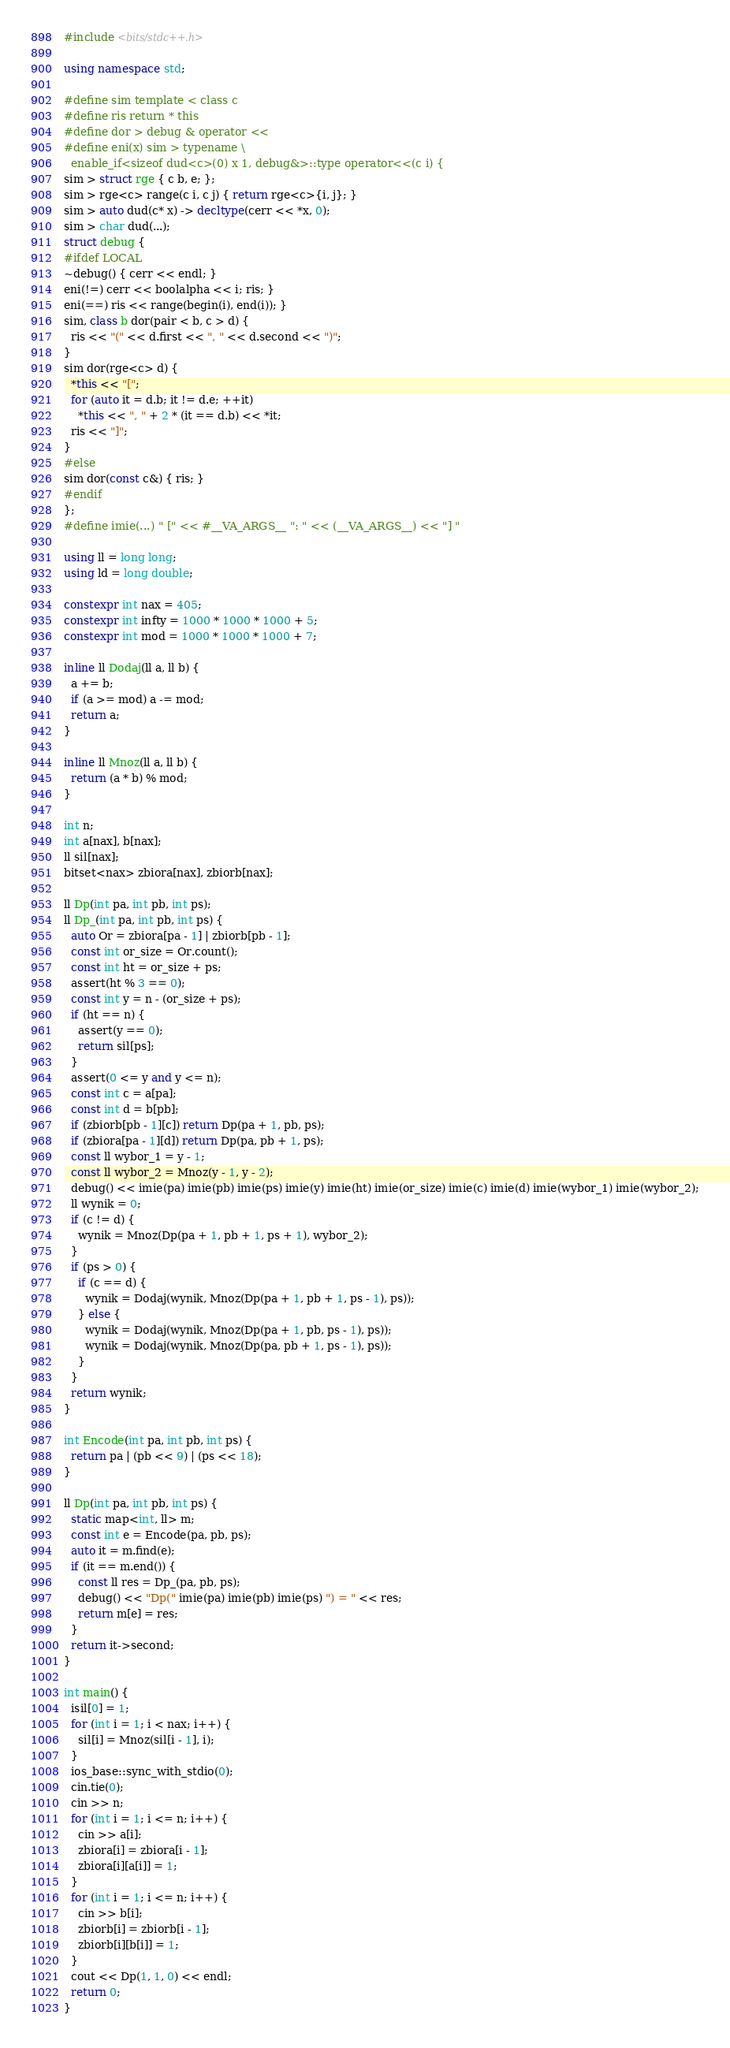<code> <loc_0><loc_0><loc_500><loc_500><_C++_>#include <bits/stdc++.h>
 
using namespace std;
 
#define sim template < class c
#define ris return * this
#define dor > debug & operator <<
#define eni(x) sim > typename \
  enable_if<sizeof dud<c>(0) x 1, debug&>::type operator<<(c i) {
sim > struct rge { c b, e; };
sim > rge<c> range(c i, c j) { return rge<c>{i, j}; }
sim > auto dud(c* x) -> decltype(cerr << *x, 0);
sim > char dud(...);
struct debug {
#ifdef LOCAL
~debug() { cerr << endl; }
eni(!=) cerr << boolalpha << i; ris; }
eni(==) ris << range(begin(i), end(i)); }
sim, class b dor(pair < b, c > d) {
  ris << "(" << d.first << ", " << d.second << ")";
}
sim dor(rge<c> d) {
  *this << "[";
  for (auto it = d.b; it != d.e; ++it)
    *this << ", " + 2 * (it == d.b) << *it;
  ris << "]";
}
#else
sim dor(const c&) { ris; }
#endif
};
#define imie(...) " [" << #__VA_ARGS__ ": " << (__VA_ARGS__) << "] "
 
using ll = long long;
using ld = long double;
 
constexpr int nax = 405;
constexpr int infty = 1000 * 1000 * 1000 + 5;
constexpr int mod = 1000 * 1000 * 1000 + 7;
 
inline ll Dodaj(ll a, ll b) {
  a += b;
  if (a >= mod) a -= mod;
  return a;
}
 
inline ll Mnoz(ll a, ll b) {
  return (a * b) % mod;
}
 
int n;
int a[nax], b[nax];
ll sil[nax];
bitset<nax> zbiora[nax], zbiorb[nax];
 
ll Dp(int pa, int pb, int ps);
ll Dp_(int pa, int pb, int ps) {
  auto Or = zbiora[pa - 1] | zbiorb[pb - 1];
  const int or_size = Or.count();
  const int ht = or_size + ps;
  assert(ht % 3 == 0);
  const int y = n - (or_size + ps);
  if (ht == n) {
    assert(y == 0);
    return sil[ps];
  }
  assert(0 <= y and y <= n);
  const int c = a[pa];
  const int d = b[pb];
  if (zbiorb[pb - 1][c]) return Dp(pa + 1, pb, ps);
  if (zbiora[pa - 1][d]) return Dp(pa, pb + 1, ps);
  const ll wybor_1 = y - 1;
  const ll wybor_2 = Mnoz(y - 1, y - 2);
  debug() << imie(pa) imie(pb) imie(ps) imie(y) imie(ht) imie(or_size) imie(c) imie(d) imie(wybor_1) imie(wybor_2);
  ll wynik = 0;
  if (c != d) {
    wynik = Mnoz(Dp(pa + 1, pb + 1, ps + 1), wybor_2);
  }
  if (ps > 0) {
    if (c == d) {
      wynik = Dodaj(wynik, Mnoz(Dp(pa + 1, pb + 1, ps - 1), ps));
    } else {
      wynik = Dodaj(wynik, Mnoz(Dp(pa + 1, pb, ps - 1), ps));
      wynik = Dodaj(wynik, Mnoz(Dp(pa, pb + 1, ps - 1), ps));
    }
  }
  return wynik;
}
 
int Encode(int pa, int pb, int ps) {
  return pa | (pb << 9) | (ps << 18);
}
 
ll Dp(int pa, int pb, int ps) {
  static map<int, ll> m;
  const int e = Encode(pa, pb, ps);
  auto it = m.find(e);
  if (it == m.end()) {
    const ll res = Dp_(pa, pb, ps);
    debug() << "Dp(" imie(pa) imie(pb) imie(ps) ") = " << res;
    return m[e] = res;
  }
  return it->second;
}
 
int main() {
  isil[0] = 1;
  for (int i = 1; i < nax; i++) {
    sil[i] = Mnoz(sil[i - 1], i);
  }
  ios_base::sync_with_stdio(0);
  cin.tie(0);
  cin >> n;
  for (int i = 1; i <= n; i++) {
    cin >> a[i];
    zbiora[i] = zbiora[i - 1];
    zbiora[i][a[i]] = 1;
  }
  for (int i = 1; i <= n; i++) {
    cin >> b[i];
    zbiorb[i] = zbiorb[i - 1];
    zbiorb[i][b[i]] = 1;
  }
  cout << Dp(1, 1, 0) << endl;
  return 0;
}
</code> 